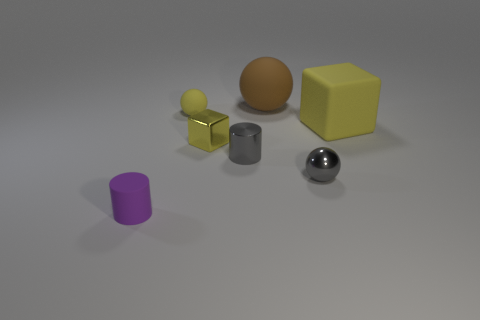Subtract all yellow rubber balls. How many balls are left? 2 Subtract 1 balls. How many balls are left? 2 Add 2 small blue rubber objects. How many objects exist? 9 Subtract all cubes. How many objects are left? 5 Subtract all purple matte things. Subtract all gray metal cylinders. How many objects are left? 5 Add 2 rubber cubes. How many rubber cubes are left? 3 Add 2 cyan things. How many cyan things exist? 2 Subtract 0 cyan blocks. How many objects are left? 7 